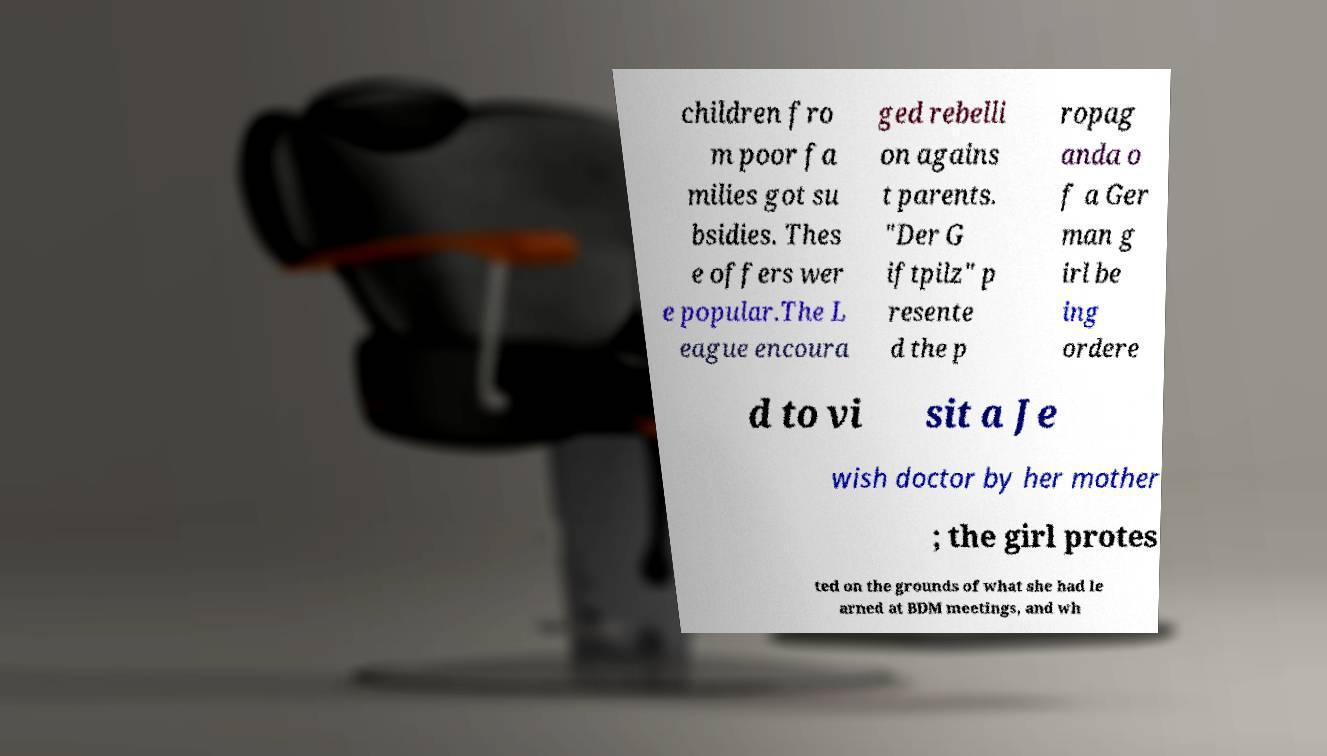There's text embedded in this image that I need extracted. Can you transcribe it verbatim? children fro m poor fa milies got su bsidies. Thes e offers wer e popular.The L eague encoura ged rebelli on agains t parents. "Der G iftpilz" p resente d the p ropag anda o f a Ger man g irl be ing ordere d to vi sit a Je wish doctor by her mother ; the girl protes ted on the grounds of what she had le arned at BDM meetings, and wh 